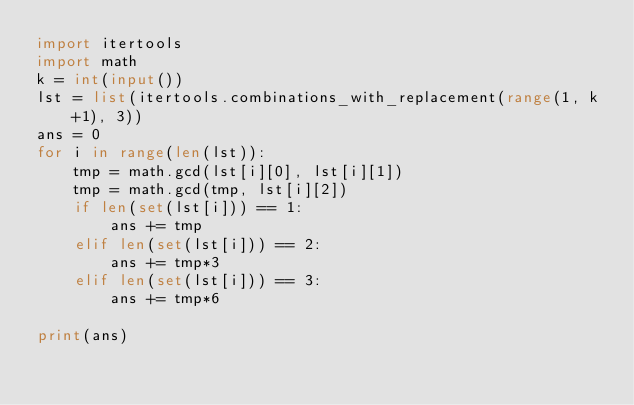Convert code to text. <code><loc_0><loc_0><loc_500><loc_500><_Python_>import itertools
import math
k = int(input())
lst = list(itertools.combinations_with_replacement(range(1, k+1), 3))
ans = 0
for i in range(len(lst)):
    tmp = math.gcd(lst[i][0], lst[i][1])
    tmp = math.gcd(tmp, lst[i][2])
    if len(set(lst[i])) == 1:
        ans += tmp
    elif len(set(lst[i])) == 2:
        ans += tmp*3
    elif len(set(lst[i])) == 3:
        ans += tmp*6

print(ans)</code> 